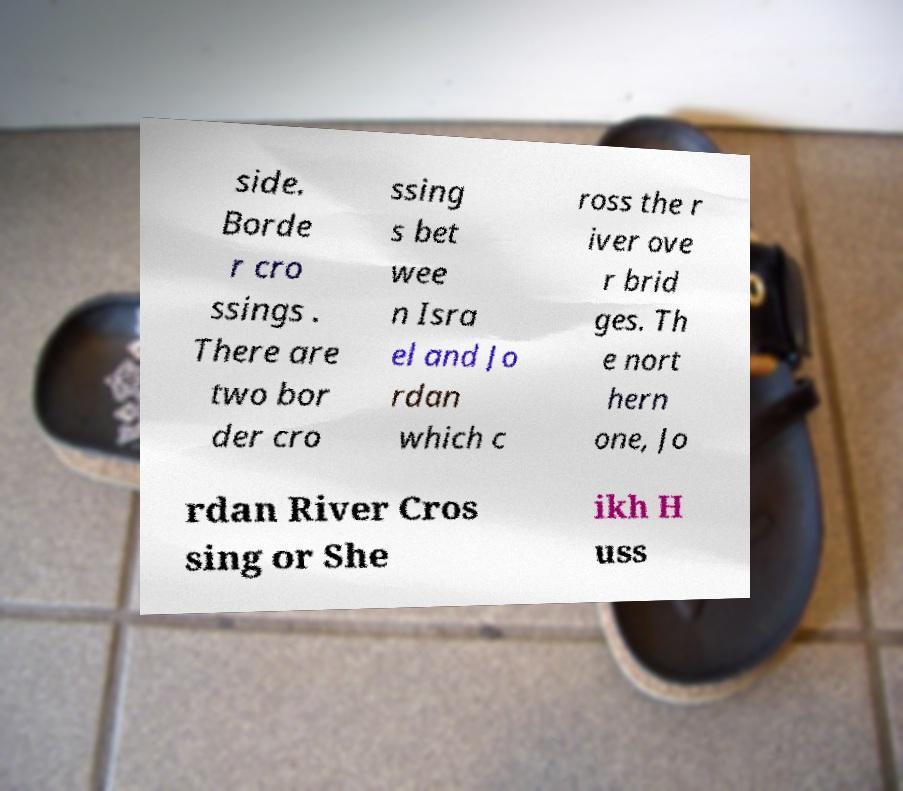I need the written content from this picture converted into text. Can you do that? side. Borde r cro ssings . There are two bor der cro ssing s bet wee n Isra el and Jo rdan which c ross the r iver ove r brid ges. Th e nort hern one, Jo rdan River Cros sing or She ikh H uss 